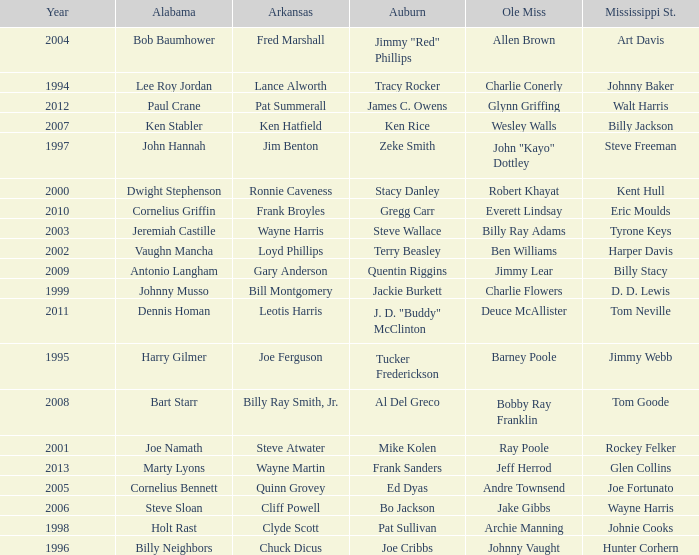Who was the Alabama player associated with Walt Harris? Paul Crane. 